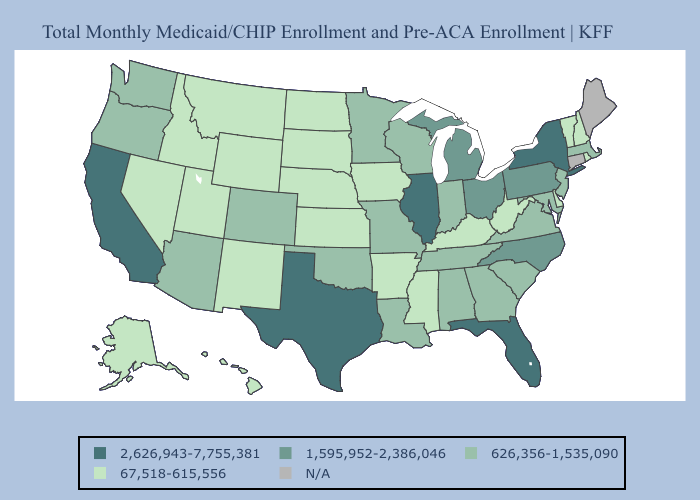Name the states that have a value in the range 2,626,943-7,755,381?
Quick response, please. California, Florida, Illinois, New York, Texas. Among the states that border Georgia , which have the lowest value?
Give a very brief answer. Alabama, South Carolina, Tennessee. Among the states that border Utah , does Colorado have the highest value?
Quick response, please. Yes. What is the value of Washington?
Concise answer only. 626,356-1,535,090. What is the lowest value in the USA?
Short answer required. 67,518-615,556. Among the states that border West Virginia , which have the highest value?
Concise answer only. Ohio, Pennsylvania. Does California have the highest value in the USA?
Concise answer only. Yes. What is the value of Nevada?
Quick response, please. 67,518-615,556. Which states hav the highest value in the West?
Give a very brief answer. California. What is the value of Alaska?
Concise answer only. 67,518-615,556. Name the states that have a value in the range 626,356-1,535,090?
Give a very brief answer. Alabama, Arizona, Colorado, Georgia, Indiana, Louisiana, Maryland, Massachusetts, Minnesota, Missouri, New Jersey, Oklahoma, Oregon, South Carolina, Tennessee, Virginia, Washington, Wisconsin. What is the value of Nevada?
Give a very brief answer. 67,518-615,556. 